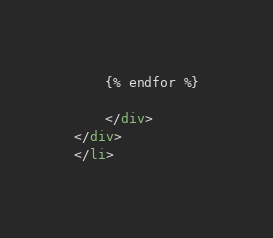<code> <loc_0><loc_0><loc_500><loc_500><_HTML_>
    {% endfor %}

    </div>
</div>
</li></code> 